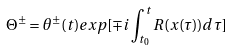<formula> <loc_0><loc_0><loc_500><loc_500>\Theta ^ { \pm } = \theta ^ { \pm } ( t ) e x p [ \mp i \int _ { t _ { 0 } } ^ { t } R ( x ( \tau ) ) d \tau ]</formula> 